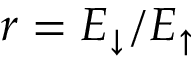Convert formula to latex. <formula><loc_0><loc_0><loc_500><loc_500>r = E _ { \downarrow } / E _ { \uparrow }</formula> 